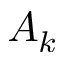Convert formula to latex. <formula><loc_0><loc_0><loc_500><loc_500>A _ { k }</formula> 